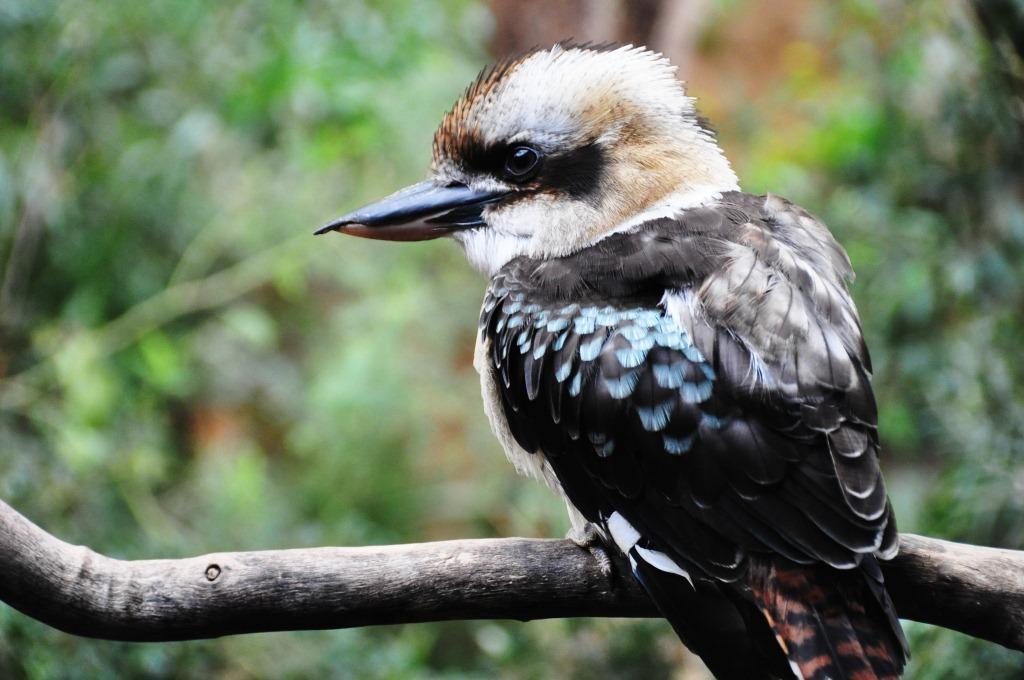Can you describe this image briefly? This image consists of a bird in white and black color. It is sitting on a stem. In the background, there are trees and plants. And the background is blurred. 